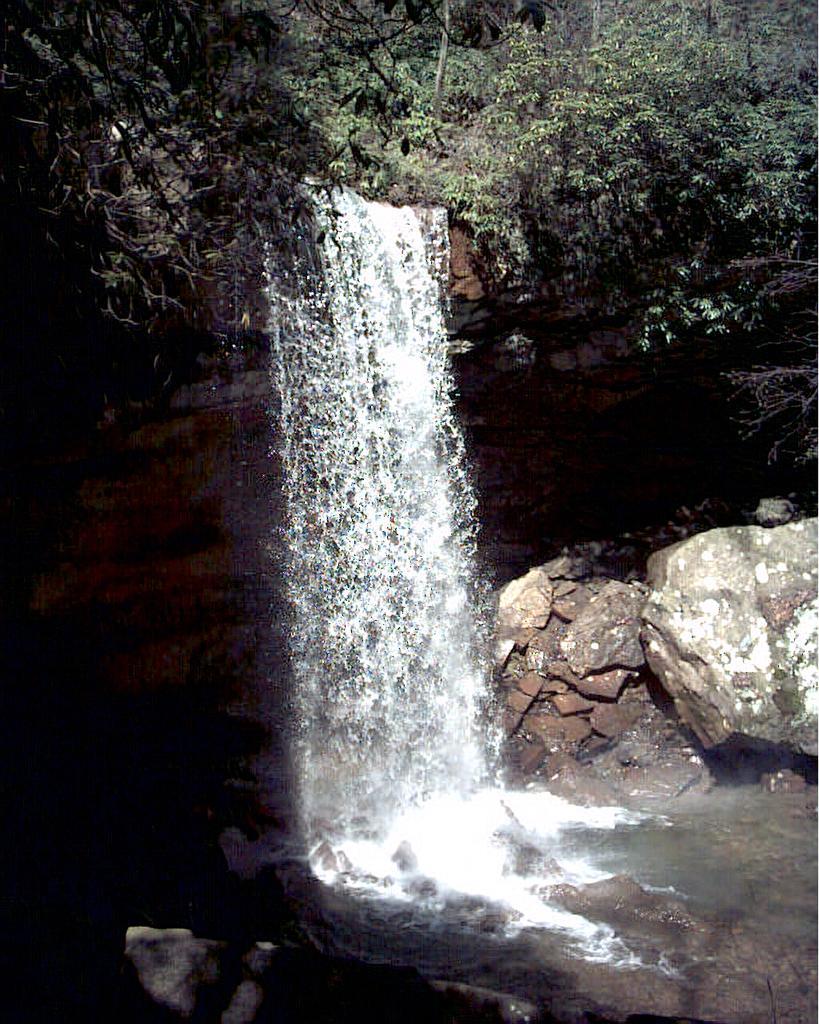In one or two sentences, can you explain what this image depicts? In this picture I can see the waterfall. On the right I can see many stones. At the top I can see many trees and plants. 